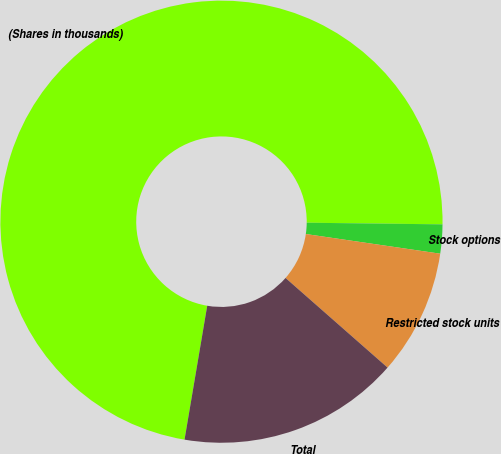Convert chart to OTSL. <chart><loc_0><loc_0><loc_500><loc_500><pie_chart><fcel>(Shares in thousands)<fcel>Stock options<fcel>Restricted stock units<fcel>Total<nl><fcel>72.52%<fcel>2.12%<fcel>9.16%<fcel>16.2%<nl></chart> 